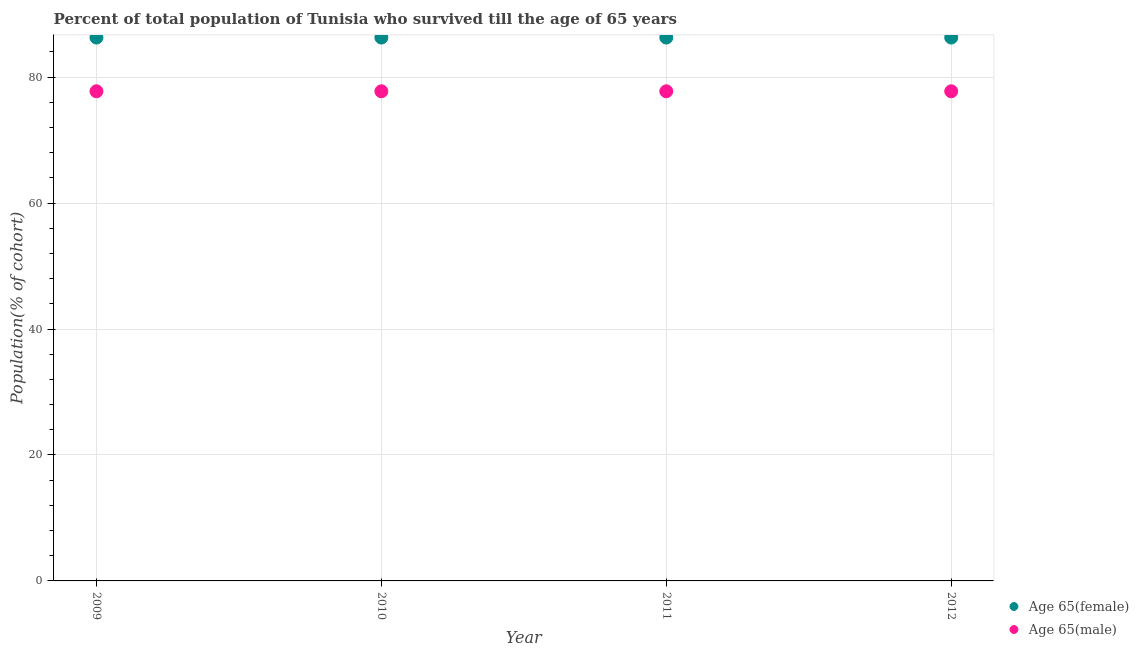How many different coloured dotlines are there?
Your answer should be compact. 2. Is the number of dotlines equal to the number of legend labels?
Provide a short and direct response. Yes. What is the percentage of female population who survived till age of 65 in 2012?
Your answer should be very brief. 86.28. Across all years, what is the maximum percentage of male population who survived till age of 65?
Make the answer very short. 77.75. Across all years, what is the minimum percentage of female population who survived till age of 65?
Provide a short and direct response. 86.28. In which year was the percentage of female population who survived till age of 65 maximum?
Your response must be concise. 2009. In which year was the percentage of female population who survived till age of 65 minimum?
Offer a terse response. 2009. What is the total percentage of female population who survived till age of 65 in the graph?
Provide a short and direct response. 345.13. What is the difference between the percentage of female population who survived till age of 65 in 2009 and that in 2011?
Your answer should be very brief. 0. What is the difference between the percentage of male population who survived till age of 65 in 2012 and the percentage of female population who survived till age of 65 in 2009?
Offer a very short reply. -8.53. What is the average percentage of female population who survived till age of 65 per year?
Offer a terse response. 86.28. In the year 2012, what is the difference between the percentage of male population who survived till age of 65 and percentage of female population who survived till age of 65?
Give a very brief answer. -8.53. What is the ratio of the percentage of male population who survived till age of 65 in 2009 to that in 2010?
Your response must be concise. 1. Is the percentage of female population who survived till age of 65 in 2010 less than that in 2011?
Make the answer very short. No. Is the difference between the percentage of female population who survived till age of 65 in 2010 and 2012 greater than the difference between the percentage of male population who survived till age of 65 in 2010 and 2012?
Provide a succinct answer. No. What is the difference between the highest and the second highest percentage of female population who survived till age of 65?
Provide a short and direct response. 0. What is the difference between the highest and the lowest percentage of male population who survived till age of 65?
Keep it short and to the point. 0. In how many years, is the percentage of male population who survived till age of 65 greater than the average percentage of male population who survived till age of 65 taken over all years?
Ensure brevity in your answer.  0. Is the sum of the percentage of male population who survived till age of 65 in 2010 and 2012 greater than the maximum percentage of female population who survived till age of 65 across all years?
Ensure brevity in your answer.  Yes. Does the percentage of male population who survived till age of 65 monotonically increase over the years?
Your answer should be compact. No. How many dotlines are there?
Your response must be concise. 2. How many years are there in the graph?
Make the answer very short. 4. Does the graph contain any zero values?
Your response must be concise. No. Does the graph contain grids?
Provide a short and direct response. Yes. Where does the legend appear in the graph?
Provide a succinct answer. Bottom right. What is the title of the graph?
Make the answer very short. Percent of total population of Tunisia who survived till the age of 65 years. What is the label or title of the X-axis?
Provide a succinct answer. Year. What is the label or title of the Y-axis?
Provide a short and direct response. Population(% of cohort). What is the Population(% of cohort) in Age 65(female) in 2009?
Offer a very short reply. 86.28. What is the Population(% of cohort) in Age 65(male) in 2009?
Your response must be concise. 77.75. What is the Population(% of cohort) in Age 65(female) in 2010?
Keep it short and to the point. 86.28. What is the Population(% of cohort) of Age 65(male) in 2010?
Keep it short and to the point. 77.75. What is the Population(% of cohort) in Age 65(female) in 2011?
Give a very brief answer. 86.28. What is the Population(% of cohort) of Age 65(male) in 2011?
Your response must be concise. 77.75. What is the Population(% of cohort) of Age 65(female) in 2012?
Keep it short and to the point. 86.28. What is the Population(% of cohort) in Age 65(male) in 2012?
Ensure brevity in your answer.  77.75. Across all years, what is the maximum Population(% of cohort) in Age 65(female)?
Provide a succinct answer. 86.28. Across all years, what is the maximum Population(% of cohort) of Age 65(male)?
Provide a succinct answer. 77.75. Across all years, what is the minimum Population(% of cohort) in Age 65(female)?
Offer a terse response. 86.28. Across all years, what is the minimum Population(% of cohort) in Age 65(male)?
Your answer should be compact. 77.75. What is the total Population(% of cohort) of Age 65(female) in the graph?
Your response must be concise. 345.13. What is the total Population(% of cohort) of Age 65(male) in the graph?
Provide a short and direct response. 311. What is the difference between the Population(% of cohort) in Age 65(male) in 2009 and that in 2010?
Make the answer very short. 0. What is the difference between the Population(% of cohort) of Age 65(male) in 2009 and that in 2011?
Offer a terse response. 0. What is the difference between the Population(% of cohort) of Age 65(male) in 2010 and that in 2012?
Give a very brief answer. 0. What is the difference between the Population(% of cohort) in Age 65(female) in 2009 and the Population(% of cohort) in Age 65(male) in 2010?
Keep it short and to the point. 8.53. What is the difference between the Population(% of cohort) in Age 65(female) in 2009 and the Population(% of cohort) in Age 65(male) in 2011?
Your answer should be compact. 8.53. What is the difference between the Population(% of cohort) in Age 65(female) in 2009 and the Population(% of cohort) in Age 65(male) in 2012?
Keep it short and to the point. 8.53. What is the difference between the Population(% of cohort) in Age 65(female) in 2010 and the Population(% of cohort) in Age 65(male) in 2011?
Your answer should be compact. 8.53. What is the difference between the Population(% of cohort) in Age 65(female) in 2010 and the Population(% of cohort) in Age 65(male) in 2012?
Keep it short and to the point. 8.53. What is the difference between the Population(% of cohort) of Age 65(female) in 2011 and the Population(% of cohort) of Age 65(male) in 2012?
Offer a terse response. 8.53. What is the average Population(% of cohort) in Age 65(female) per year?
Make the answer very short. 86.28. What is the average Population(% of cohort) of Age 65(male) per year?
Provide a succinct answer. 77.75. In the year 2009, what is the difference between the Population(% of cohort) in Age 65(female) and Population(% of cohort) in Age 65(male)?
Offer a very short reply. 8.53. In the year 2010, what is the difference between the Population(% of cohort) in Age 65(female) and Population(% of cohort) in Age 65(male)?
Your answer should be very brief. 8.53. In the year 2011, what is the difference between the Population(% of cohort) in Age 65(female) and Population(% of cohort) in Age 65(male)?
Provide a succinct answer. 8.53. In the year 2012, what is the difference between the Population(% of cohort) of Age 65(female) and Population(% of cohort) of Age 65(male)?
Make the answer very short. 8.53. What is the ratio of the Population(% of cohort) of Age 65(female) in 2009 to that in 2010?
Your answer should be very brief. 1. What is the ratio of the Population(% of cohort) of Age 65(male) in 2009 to that in 2010?
Make the answer very short. 1. What is the ratio of the Population(% of cohort) of Age 65(female) in 2009 to that in 2011?
Make the answer very short. 1. What is the ratio of the Population(% of cohort) of Age 65(male) in 2009 to that in 2012?
Make the answer very short. 1. What is the ratio of the Population(% of cohort) in Age 65(male) in 2010 to that in 2011?
Give a very brief answer. 1. What is the ratio of the Population(% of cohort) of Age 65(male) in 2010 to that in 2012?
Provide a succinct answer. 1. What is the ratio of the Population(% of cohort) in Age 65(male) in 2011 to that in 2012?
Offer a terse response. 1. What is the difference between the highest and the lowest Population(% of cohort) in Age 65(female)?
Give a very brief answer. 0. What is the difference between the highest and the lowest Population(% of cohort) of Age 65(male)?
Your answer should be very brief. 0. 